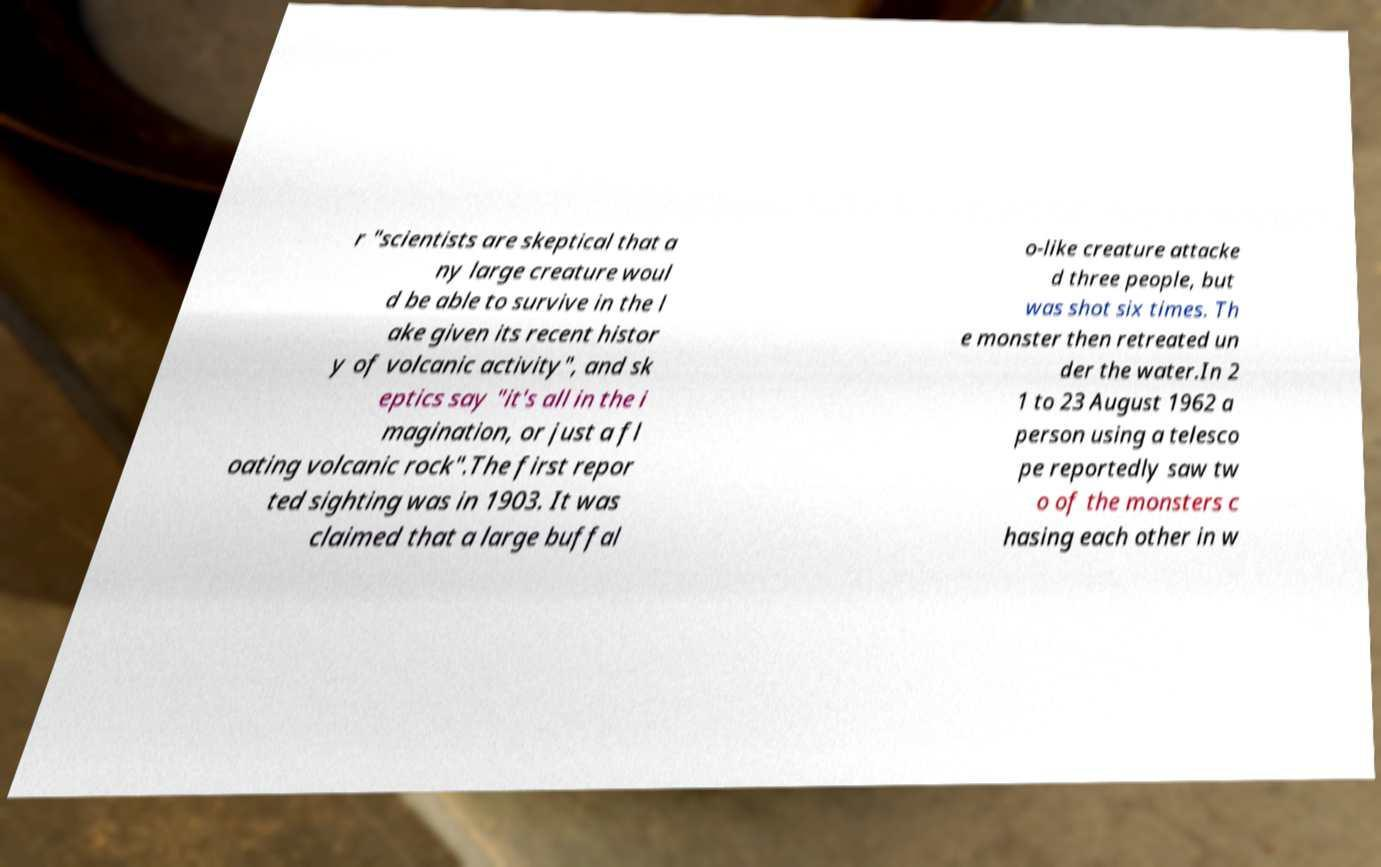Could you extract and type out the text from this image? r "scientists are skeptical that a ny large creature woul d be able to survive in the l ake given its recent histor y of volcanic activity", and sk eptics say "it's all in the i magination, or just a fl oating volcanic rock".The first repor ted sighting was in 1903. It was claimed that a large buffal o-like creature attacke d three people, but was shot six times. Th e monster then retreated un der the water.In 2 1 to 23 August 1962 a person using a telesco pe reportedly saw tw o of the monsters c hasing each other in w 